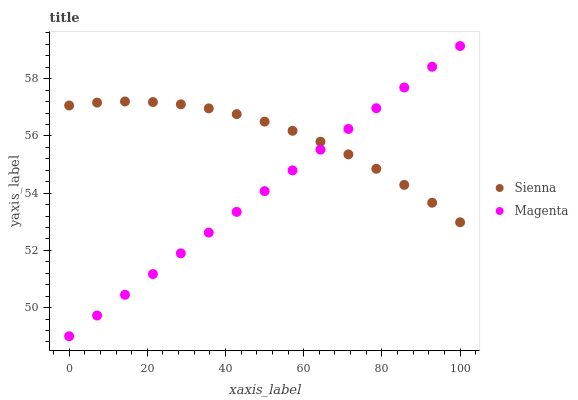Does Magenta have the minimum area under the curve?
Answer yes or no. Yes. Does Sienna have the maximum area under the curve?
Answer yes or no. Yes. Does Magenta have the maximum area under the curve?
Answer yes or no. No. Is Magenta the smoothest?
Answer yes or no. Yes. Is Sienna the roughest?
Answer yes or no. Yes. Is Magenta the roughest?
Answer yes or no. No. Does Magenta have the lowest value?
Answer yes or no. Yes. Does Magenta have the highest value?
Answer yes or no. Yes. Does Sienna intersect Magenta?
Answer yes or no. Yes. Is Sienna less than Magenta?
Answer yes or no. No. Is Sienna greater than Magenta?
Answer yes or no. No. 